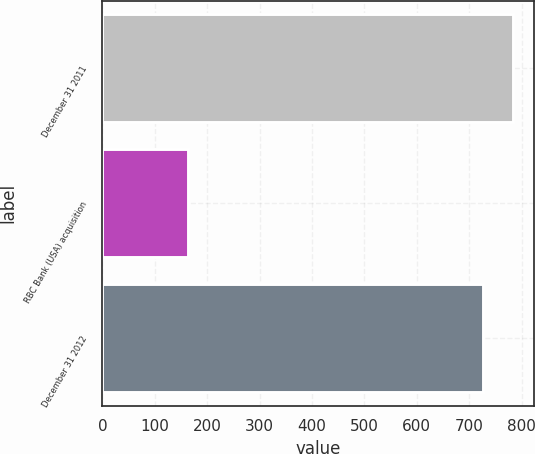Convert chart. <chart><loc_0><loc_0><loc_500><loc_500><bar_chart><fcel>December 31 2011<fcel>RBC Bank (USA) acquisition<fcel>December 31 2012<nl><fcel>783.8<fcel>164<fcel>726<nl></chart> 